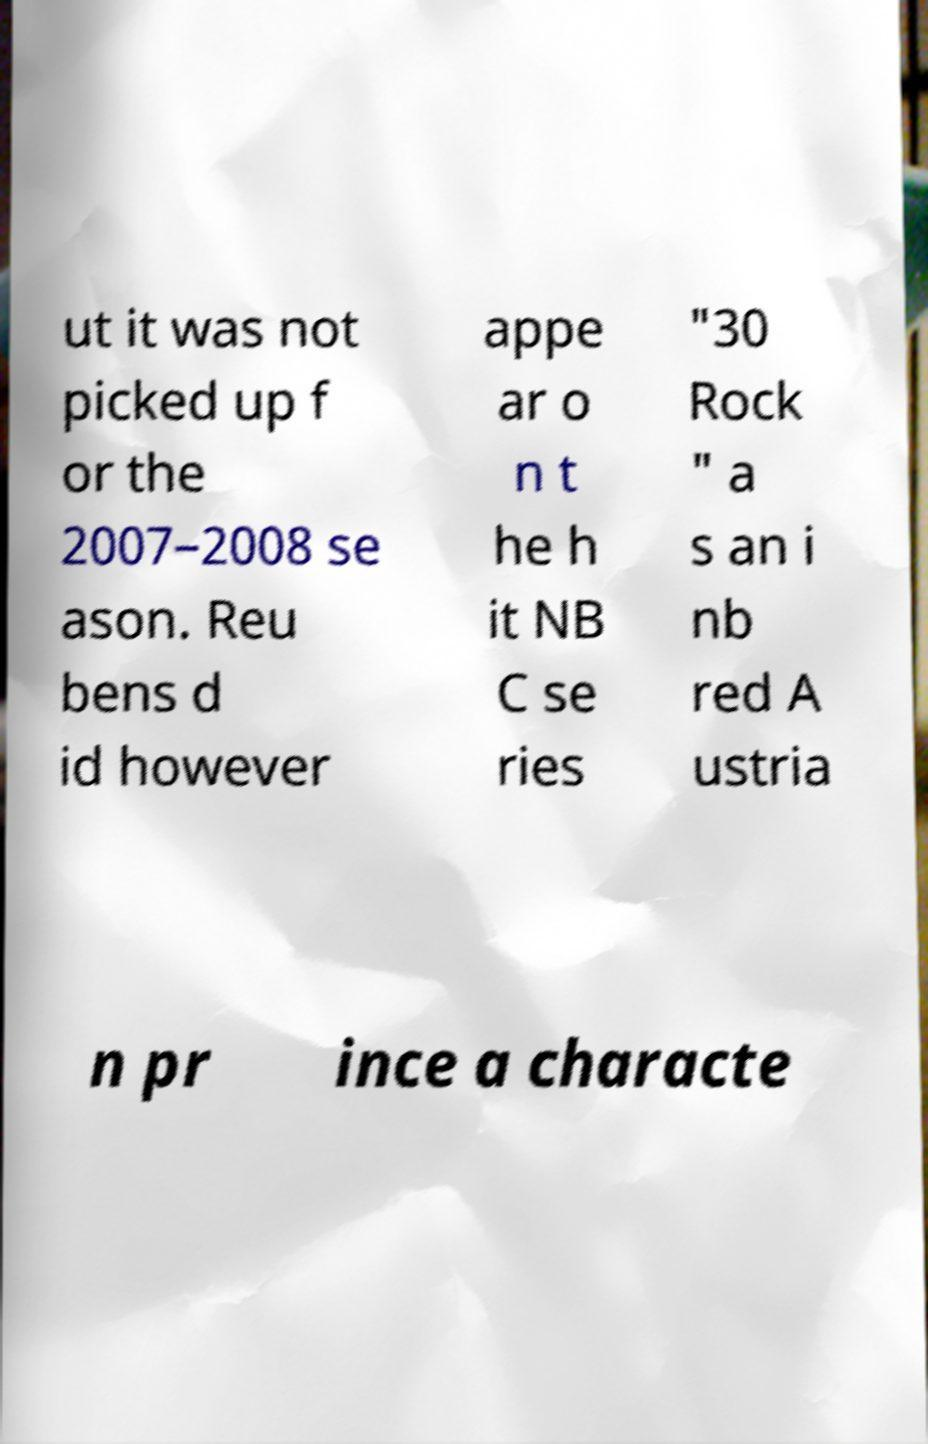Could you assist in decoding the text presented in this image and type it out clearly? ut it was not picked up f or the 2007–2008 se ason. Reu bens d id however appe ar o n t he h it NB C se ries "30 Rock " a s an i nb red A ustria n pr ince a characte 